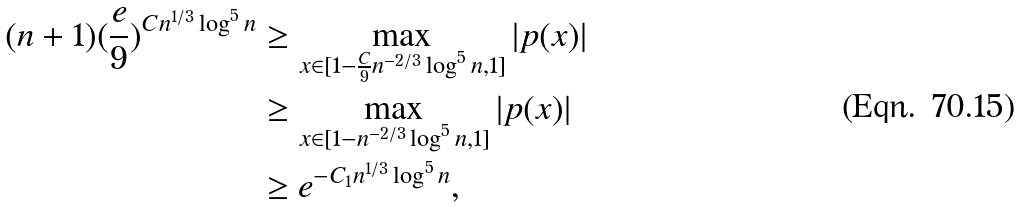<formula> <loc_0><loc_0><loc_500><loc_500>( n + 1 ) ( \frac { e } { 9 } ) ^ { C n ^ { 1 / 3 } \log ^ { 5 } n } & \geq \max _ { x \in [ 1 - \frac { C } { 9 } n ^ { - 2 / 3 } \log ^ { 5 } n , 1 ] } | p ( x ) | \\ & \geq \max _ { x \in [ 1 - n ^ { - 2 / 3 } \log ^ { 5 } n , 1 ] } | p ( x ) | \\ & \geq e ^ { - C _ { 1 } n ^ { 1 / 3 } \log ^ { 5 } n } ,</formula> 